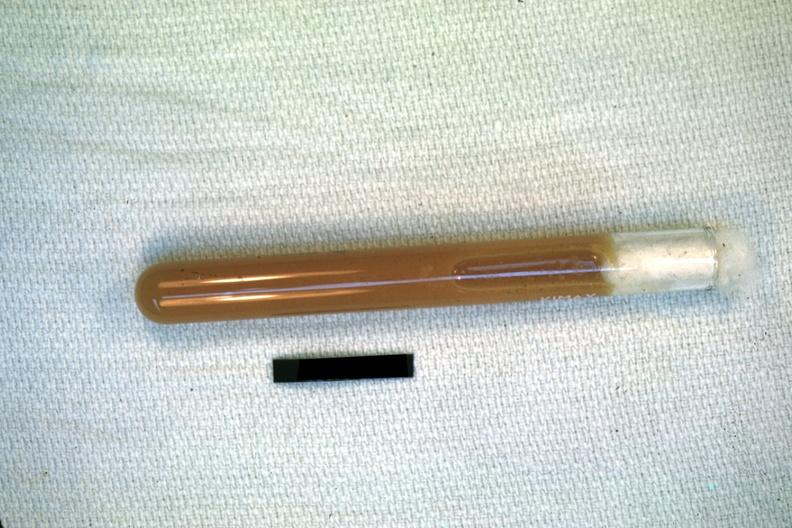what is present?
Answer the question using a single word or phrase. Abdomen 